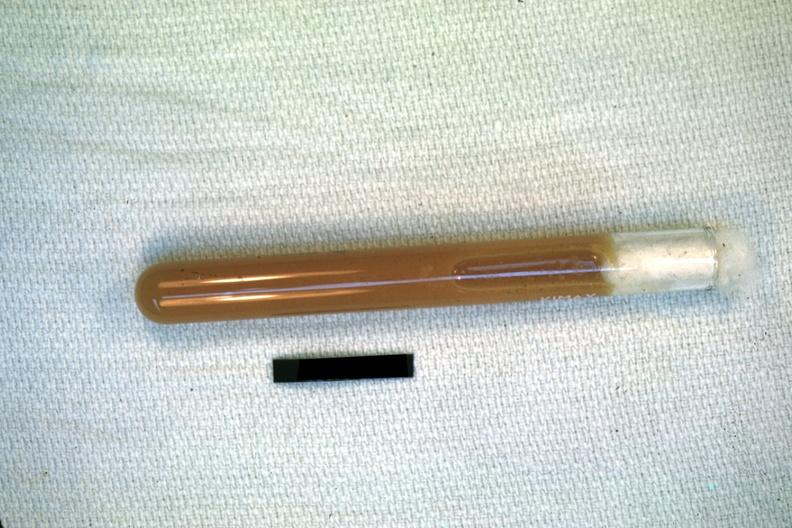what is present?
Answer the question using a single word or phrase. Abdomen 